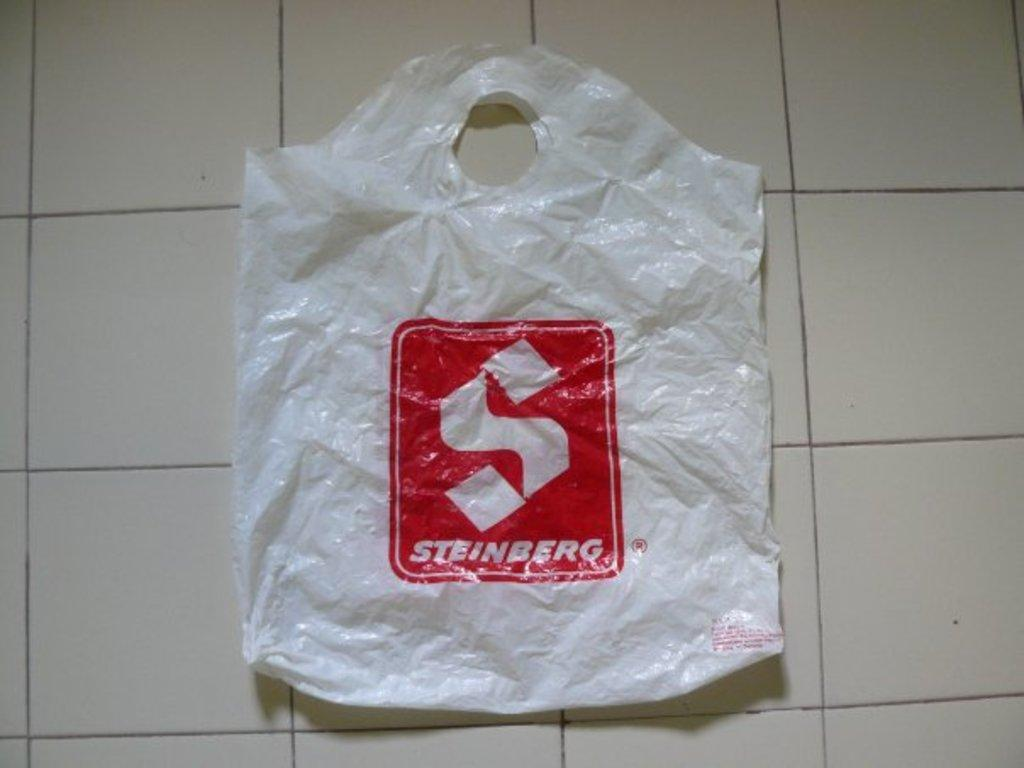What is placed on the white surface in the image? There is a cover on a white surface in the image. What can be seen on the cover? There is text on the cover. How does the knife interact with the snow in the image? There is no knife or snow present in the image; it only features a cover with text on a white surface. 